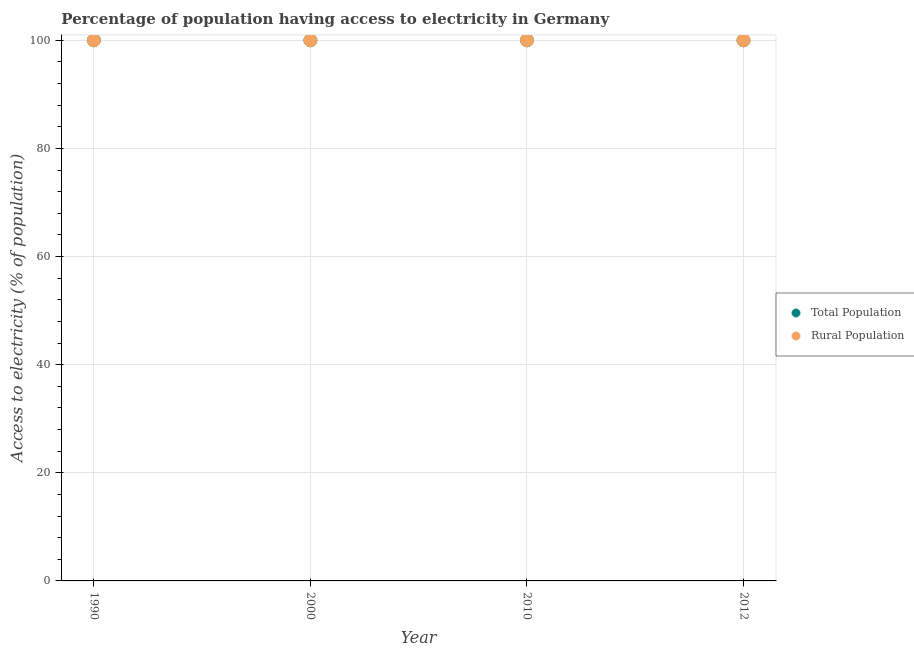How many different coloured dotlines are there?
Give a very brief answer. 2. Is the number of dotlines equal to the number of legend labels?
Give a very brief answer. Yes. What is the percentage of population having access to electricity in 2000?
Your answer should be compact. 100. Across all years, what is the maximum percentage of rural population having access to electricity?
Your response must be concise. 100. Across all years, what is the minimum percentage of rural population having access to electricity?
Your answer should be very brief. 100. What is the total percentage of population having access to electricity in the graph?
Make the answer very short. 400. What is the difference between the percentage of population having access to electricity in 1990 and that in 2000?
Offer a very short reply. 0. What is the difference between the percentage of population having access to electricity in 2012 and the percentage of rural population having access to electricity in 1990?
Offer a terse response. 0. What is the average percentage of rural population having access to electricity per year?
Your answer should be compact. 100. In how many years, is the percentage of rural population having access to electricity greater than 8 %?
Keep it short and to the point. 4. What is the ratio of the percentage of rural population having access to electricity in 2010 to that in 2012?
Your answer should be very brief. 1. Is the percentage of rural population having access to electricity in 2010 less than that in 2012?
Provide a short and direct response. No. Is the difference between the percentage of population having access to electricity in 2010 and 2012 greater than the difference between the percentage of rural population having access to electricity in 2010 and 2012?
Give a very brief answer. No. Does the percentage of population having access to electricity monotonically increase over the years?
Provide a succinct answer. No. How many dotlines are there?
Provide a short and direct response. 2. Are the values on the major ticks of Y-axis written in scientific E-notation?
Offer a terse response. No. Does the graph contain grids?
Make the answer very short. Yes. How many legend labels are there?
Make the answer very short. 2. How are the legend labels stacked?
Provide a short and direct response. Vertical. What is the title of the graph?
Provide a succinct answer. Percentage of population having access to electricity in Germany. Does "Drinking water services" appear as one of the legend labels in the graph?
Your answer should be compact. No. What is the label or title of the X-axis?
Make the answer very short. Year. What is the label or title of the Y-axis?
Make the answer very short. Access to electricity (% of population). What is the Access to electricity (% of population) in Total Population in 1990?
Ensure brevity in your answer.  100. What is the Access to electricity (% of population) of Rural Population in 1990?
Ensure brevity in your answer.  100. What is the Access to electricity (% of population) of Total Population in 2000?
Your answer should be very brief. 100. What is the Access to electricity (% of population) of Rural Population in 2012?
Your response must be concise. 100. Across all years, what is the maximum Access to electricity (% of population) in Rural Population?
Your response must be concise. 100. Across all years, what is the minimum Access to electricity (% of population) of Rural Population?
Your answer should be compact. 100. What is the total Access to electricity (% of population) in Rural Population in the graph?
Keep it short and to the point. 400. What is the difference between the Access to electricity (% of population) of Total Population in 1990 and that in 2000?
Keep it short and to the point. 0. What is the difference between the Access to electricity (% of population) in Total Population in 1990 and that in 2010?
Your answer should be compact. 0. What is the difference between the Access to electricity (% of population) of Rural Population in 1990 and that in 2010?
Provide a short and direct response. 0. What is the difference between the Access to electricity (% of population) of Total Population in 2000 and that in 2012?
Your answer should be very brief. 0. What is the difference between the Access to electricity (% of population) of Total Population in 2010 and that in 2012?
Keep it short and to the point. 0. What is the difference between the Access to electricity (% of population) in Rural Population in 2010 and that in 2012?
Keep it short and to the point. 0. What is the difference between the Access to electricity (% of population) of Total Population in 1990 and the Access to electricity (% of population) of Rural Population in 2000?
Ensure brevity in your answer.  0. What is the difference between the Access to electricity (% of population) in Total Population in 1990 and the Access to electricity (% of population) in Rural Population in 2012?
Ensure brevity in your answer.  0. What is the difference between the Access to electricity (% of population) in Total Population in 2000 and the Access to electricity (% of population) in Rural Population in 2010?
Your response must be concise. 0. What is the average Access to electricity (% of population) in Rural Population per year?
Give a very brief answer. 100. In the year 2000, what is the difference between the Access to electricity (% of population) of Total Population and Access to electricity (% of population) of Rural Population?
Your response must be concise. 0. What is the ratio of the Access to electricity (% of population) of Total Population in 1990 to that in 2000?
Keep it short and to the point. 1. What is the ratio of the Access to electricity (% of population) in Rural Population in 1990 to that in 2000?
Your answer should be compact. 1. What is the ratio of the Access to electricity (% of population) of Total Population in 1990 to that in 2010?
Offer a terse response. 1. What is the ratio of the Access to electricity (% of population) in Total Population in 1990 to that in 2012?
Keep it short and to the point. 1. What is the ratio of the Access to electricity (% of population) in Rural Population in 2000 to that in 2010?
Offer a terse response. 1. What is the ratio of the Access to electricity (% of population) of Total Population in 2010 to that in 2012?
Provide a succinct answer. 1. What is the difference between the highest and the second highest Access to electricity (% of population) of Rural Population?
Offer a very short reply. 0. What is the difference between the highest and the lowest Access to electricity (% of population) of Rural Population?
Offer a very short reply. 0. 